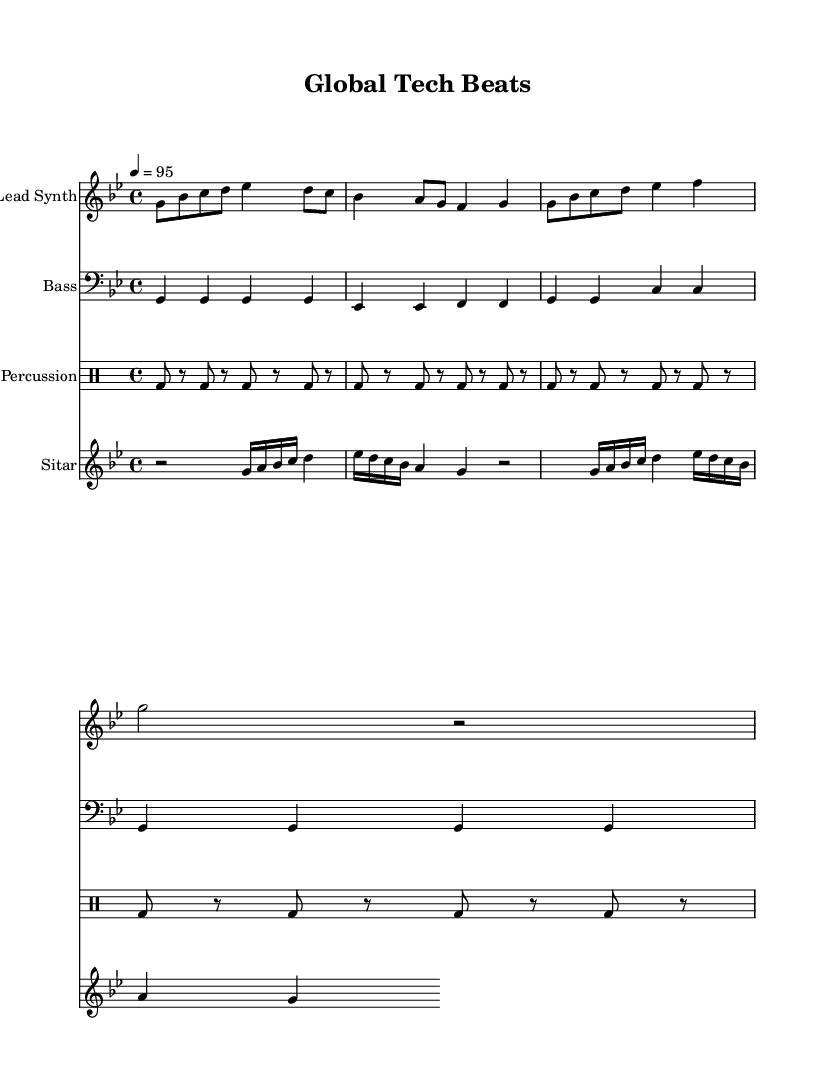What is the key signature of this music? The key signature is G minor, which has two flats (B flat and E flat). This is determined by examining the key signature section at the beginning of the score.
Answer: G minor What is the time signature of this music? The time signature is 4/4, which indicates four beats per measure. This can be found in the section indicating the meter at the start, right next to the key signature.
Answer: 4/4 What is the tempo marking of this piece? The tempo marking is 95 beats per minute, indicated at the beginning of the score with the notation "4 = 95". This shows how many beats occur in one minute.
Answer: 95 How many measures are in the lead synth part? Counting the segments of the lead synth staff reveals there are 8 measures. Each measure is separated by vertical bar lines.
Answer: 8 Which instrument plays the bass part? The bass part is played by the Bass instrument, as denoted at the beginning of its section. This instrument is notated on the bass clef staff.
Answer: Bass What genre does this music represent? The music represents the Hip Hop genre, as can be inferred from the context in the title and lyrics reflecting themes of innovation and global reach.
Answer: Hip Hop What is the main theme expressed in the chorus? The main theme expressed in the chorus revolves around innovation and globalization, emphasizing the idea that the startup is making an impact across borders. This can be understood by analyzing the lyrics of the chorus.
Answer: Global Tech Beats 